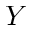<formula> <loc_0><loc_0><loc_500><loc_500>Y</formula> 